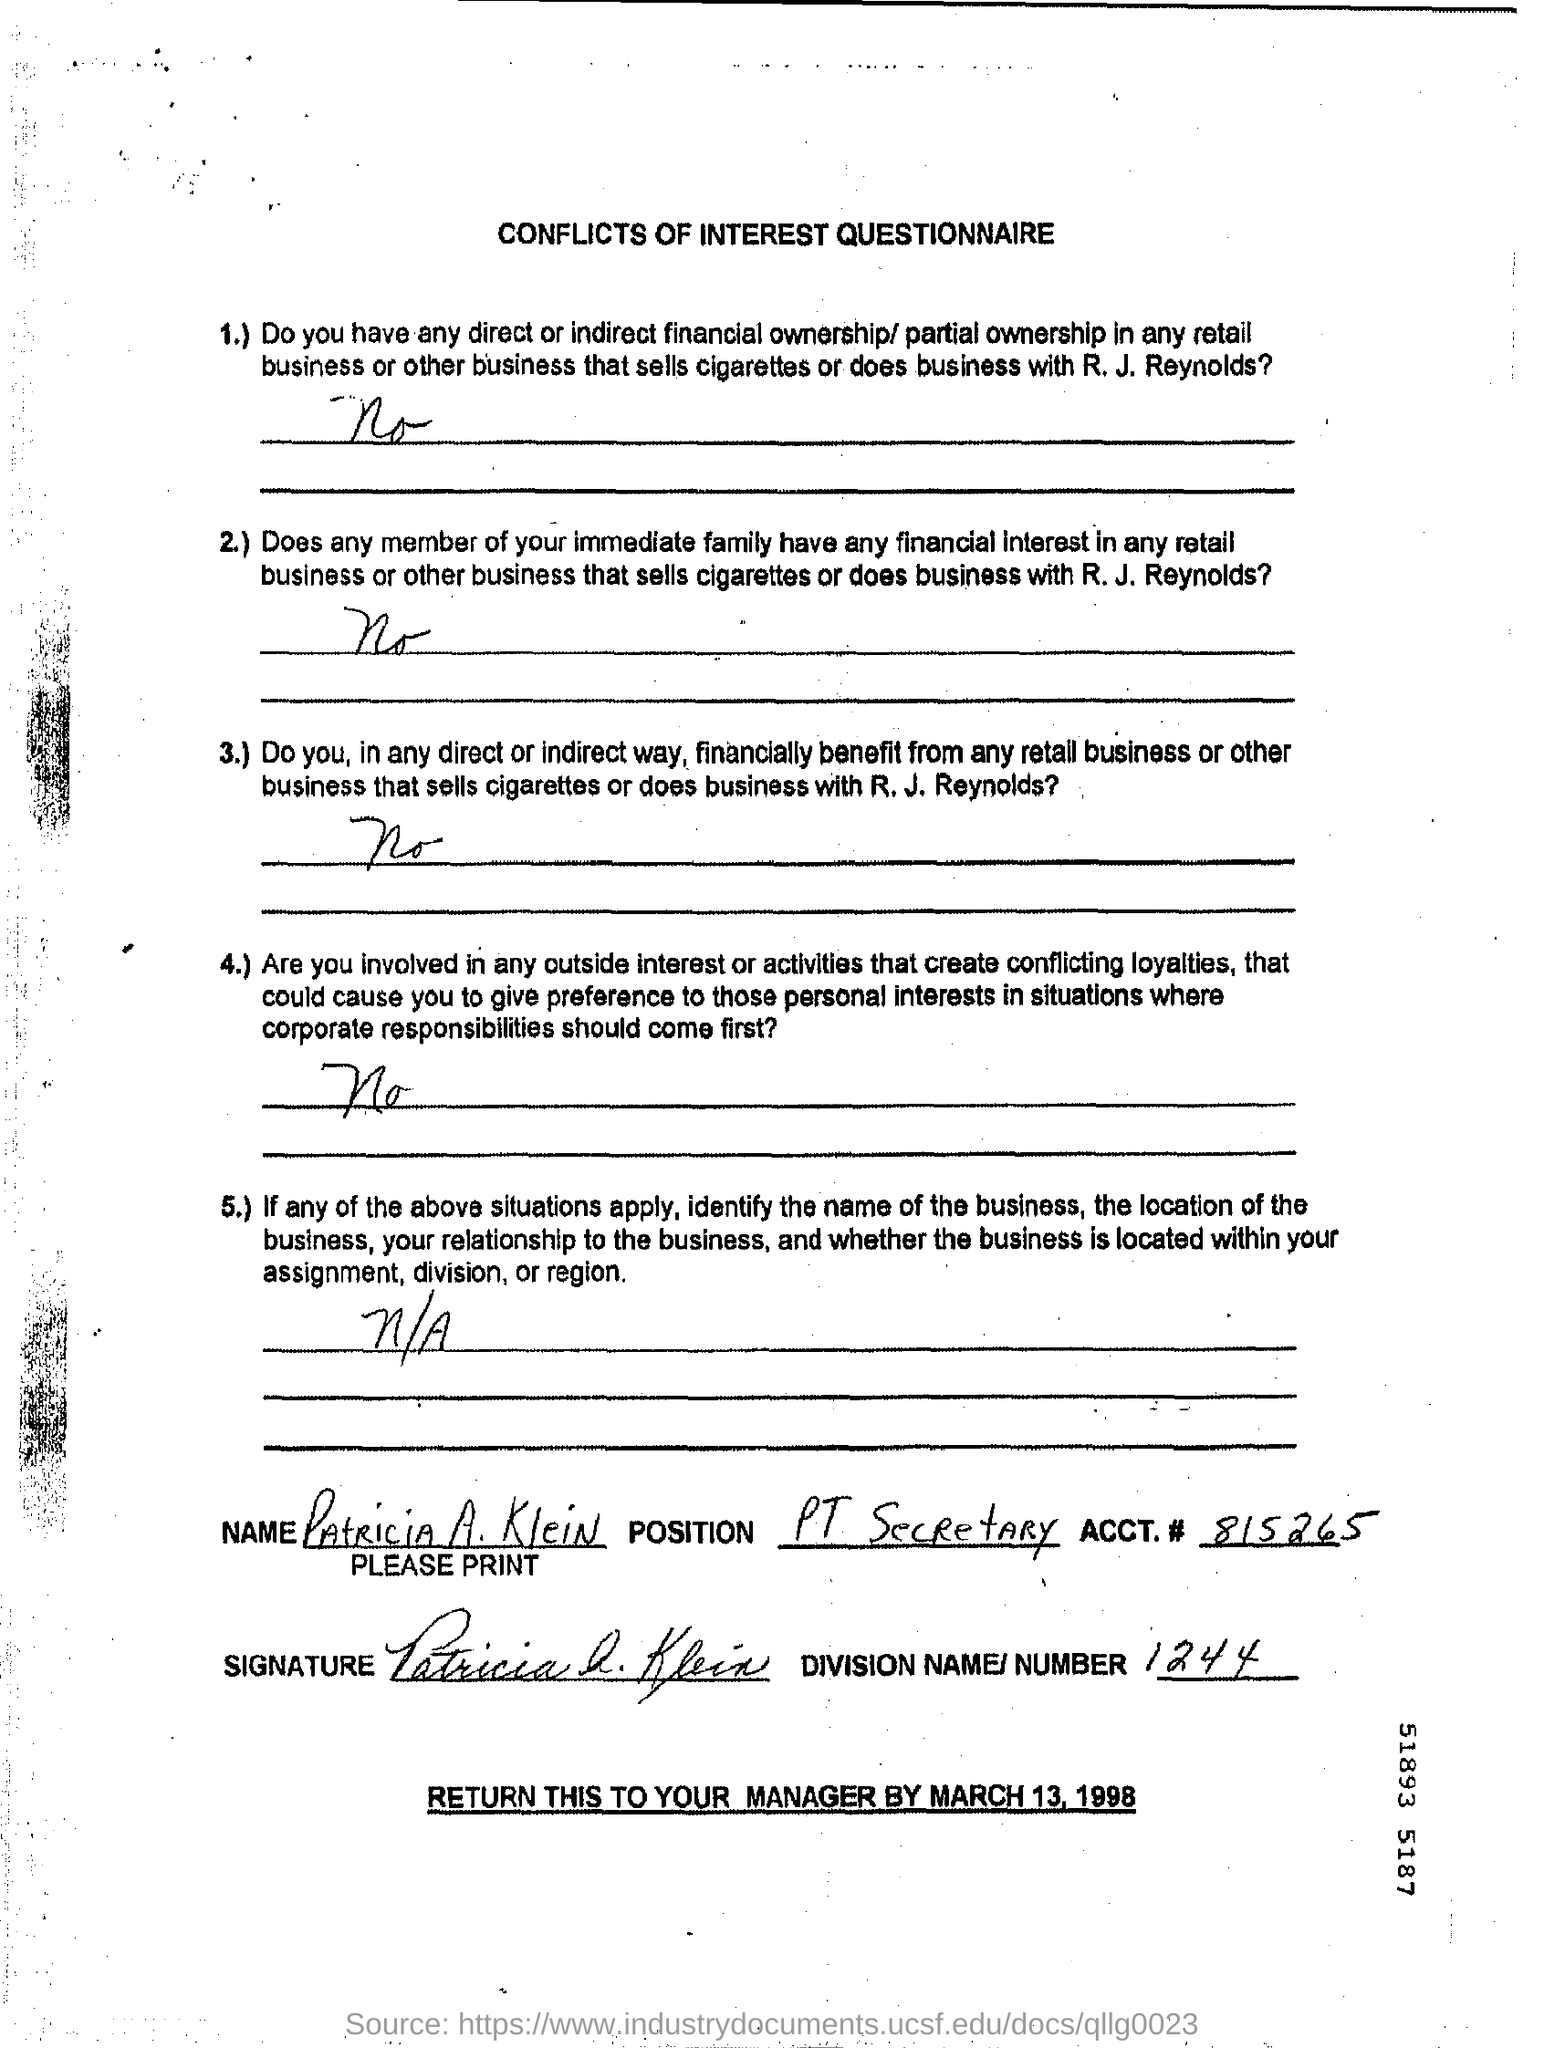Point out several critical features in this image. The account number given in the document is 815265... This document is titled 'Conflicts of Interest Questionnaire.' The document should be returned to the manager on March 13, 1998. The name mentioned in the document is "Patricia A. Klein. The division number given is 1244. 